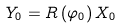Convert formula to latex. <formula><loc_0><loc_0><loc_500><loc_500>Y _ { 0 } = R \left ( \varphi _ { 0 } \right ) X _ { 0 }</formula> 